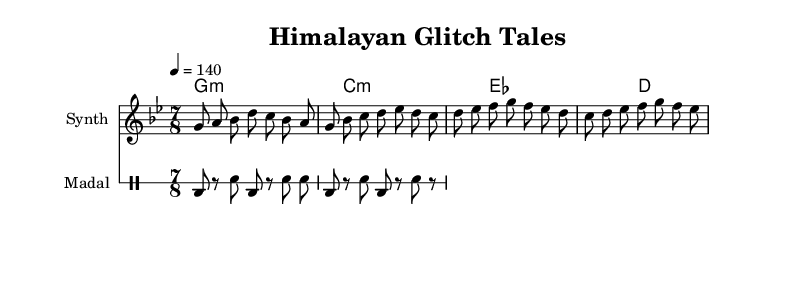What is the key signature of this music? The key signature indicated in the music sheet is G minor, which consists of two flats (B flat and E flat).
Answer: G minor What is the time signature of this music? The time signature shown in the music sheet is 7/8, meaning there are seven eighth notes in each measure.
Answer: 7/8 What is the tempo marking of this music? The tempo marking indicates a speed of 140 beats per minute, which suggests a lively pace for the performance.
Answer: 140 How many measures are in the melody? The melody section contains a total of 4 measures, which can be counted by looking at the bar lines in the music.
Answer: 4 What percussion instrument is used in the rhythmic section? The rhythmic section specifies a "Madal," which is a traditional Nepali drum instrument that complements the electronic elements in the piece.
Answer: Madal What is the first note of the main theme? The first note of the main theme is G, which is also indicated by the note on the staff at the beginning of the melody section.
Answer: G Which melodic figure runs through the piece as a variation? The variation in the melody starts with D, based on the sequence outlined in the music sheet after the main theme indicated previously.
Answer: D 